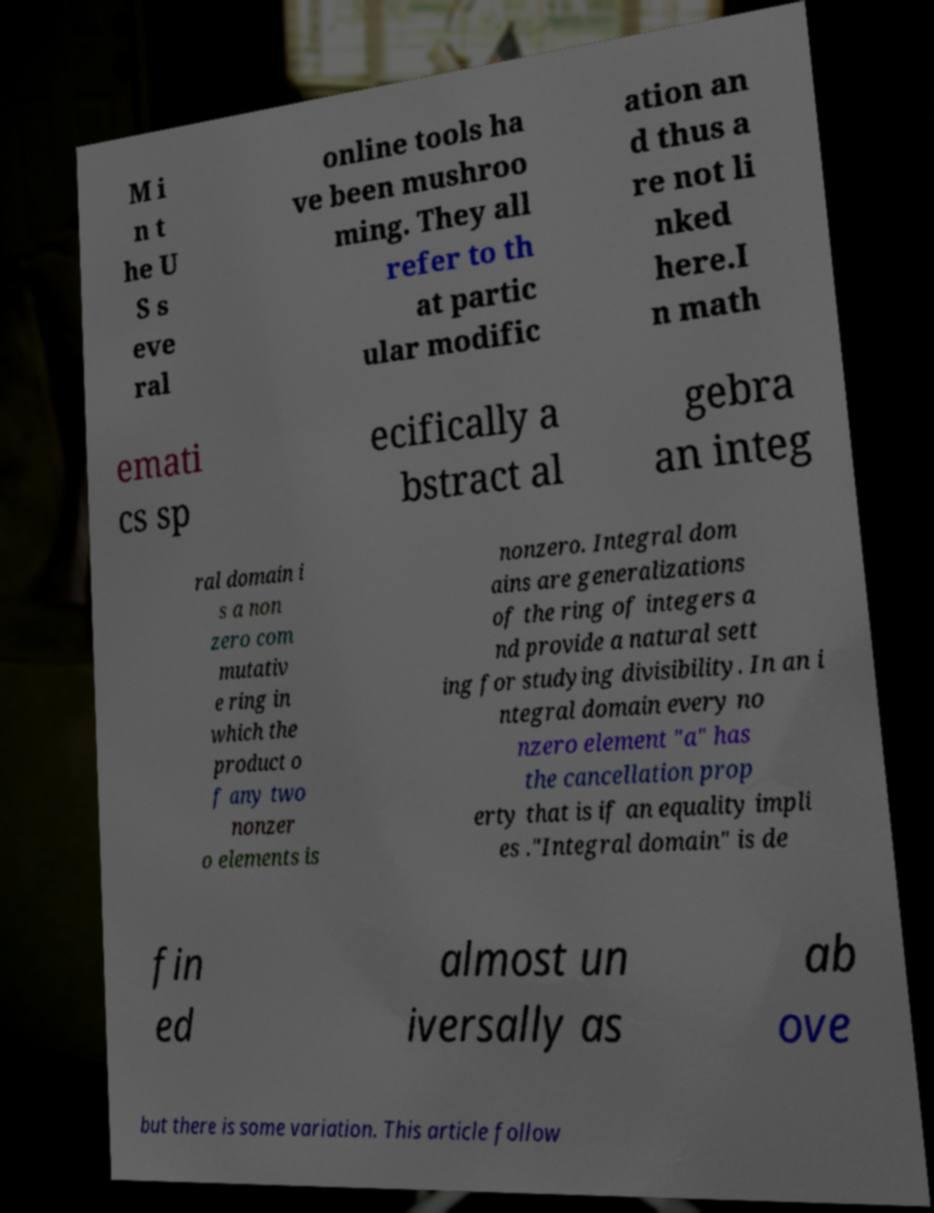I need the written content from this picture converted into text. Can you do that? M i n t he U S s eve ral online tools ha ve been mushroo ming. They all refer to th at partic ular modific ation an d thus a re not li nked here.I n math emati cs sp ecifically a bstract al gebra an integ ral domain i s a non zero com mutativ e ring in which the product o f any two nonzer o elements is nonzero. Integral dom ains are generalizations of the ring of integers a nd provide a natural sett ing for studying divisibility. In an i ntegral domain every no nzero element "a" has the cancellation prop erty that is if an equality impli es ."Integral domain" is de fin ed almost un iversally as ab ove but there is some variation. This article follow 